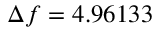Convert formula to latex. <formula><loc_0><loc_0><loc_500><loc_500>\Delta f = 4 . 9 6 1 3 3</formula> 